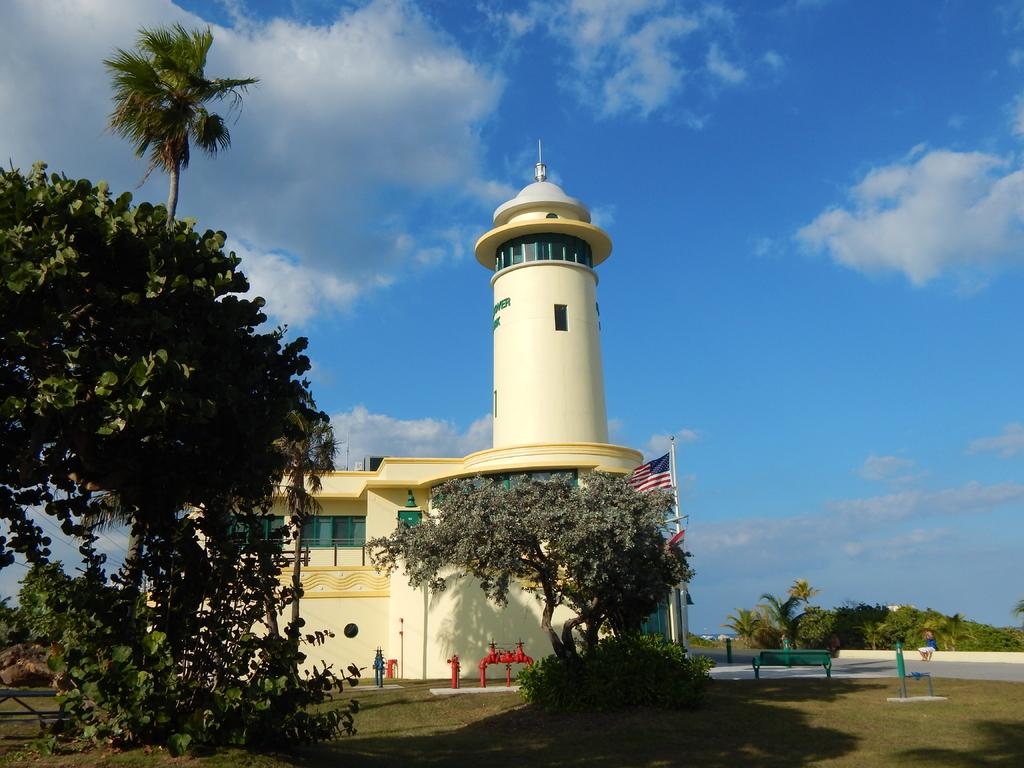What type of structure is visible in the image? There is a building with windows in the image. What other natural elements can be seen in the image? There are trees in the image. What type of seating is available in the image? There is a bench on the ground in the image. What is the person in the image doing? A person is sitting on a wall in the image. What symbol or emblem is present in the image? There is a flag in the image. What can be seen in the background of the image? The sky with clouds is visible in the background of the image. Where can the owner of the building be found in the image? There is no information about the building's owner in the image, so it cannot be determined where they might be. 